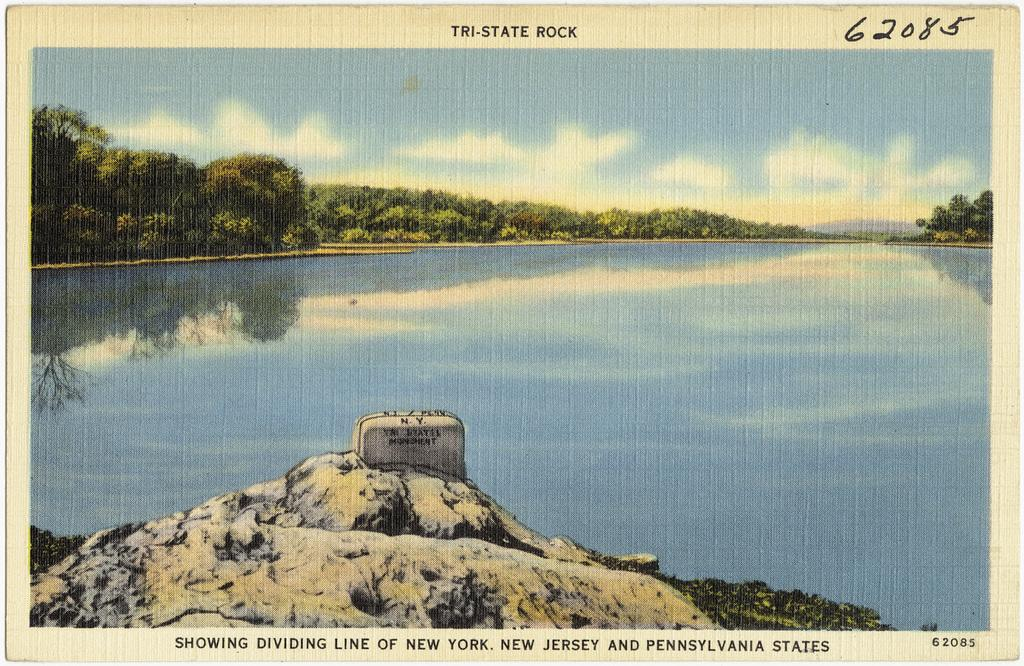What is located in the foreground of the image? There is a rock and grass in the foreground of the image. What can be seen in the background of the image? There is water, trees, sky, and a cloud in the background of the image. How much debt is the rock in the image responsible for? There is no information about debt in the image, as it features a rock and grass in the foreground and water, trees, sky, and a cloud in the background. 